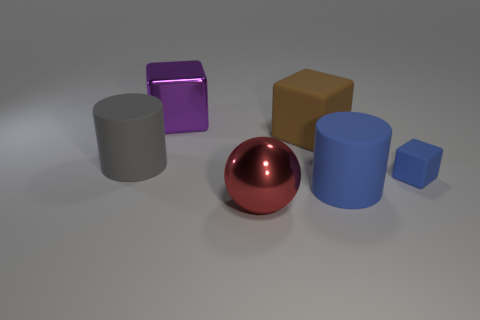Subtract all large brown cubes. How many cubes are left? 2 Add 2 large purple objects. How many objects exist? 8 Subtract 1 cubes. How many cubes are left? 2 Subtract all blue matte things. Subtract all big purple cubes. How many objects are left? 3 Add 1 small rubber objects. How many small rubber objects are left? 2 Add 6 small red rubber cubes. How many small red rubber cubes exist? 6 Subtract 0 brown balls. How many objects are left? 6 Subtract all cylinders. How many objects are left? 4 Subtract all red blocks. Subtract all blue cylinders. How many blocks are left? 3 